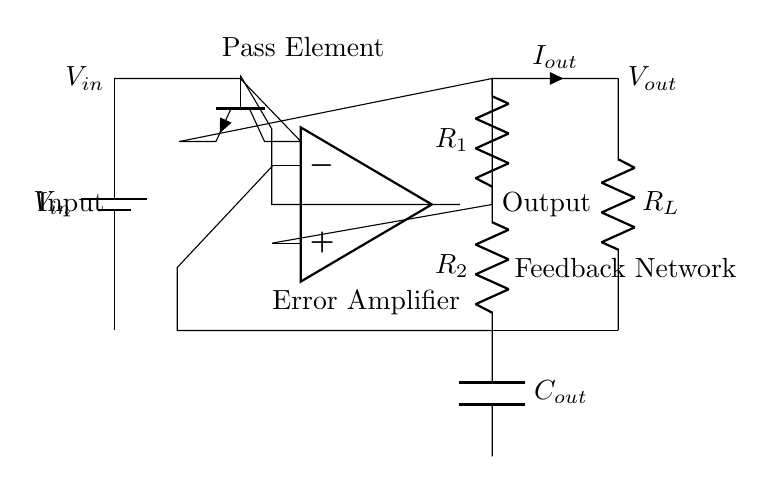What is the input voltage in this circuit? The input voltage is labeled as V_in, which indicates the source voltage provided to the circuit.
Answer: V_in What type of transistor is used as the pass element in this regulator? The circuit diagram shows an npn transistor indicated by the symbol drawn at the lower left as the pass element.
Answer: npn What does the feedback network consist of in this circuit? The feedback network consists of two resistors labeled R_1 and R_2 in the voltage divider configuration between the output and the inverting terminal of the op-amp.
Answer: Resistors R_1 and R_2 What is the purpose of the error amplifier in this circuit? The error amplifier, depicted as an op-amp, compares the output voltage to a reference voltage to control the pass element and maintain a stable output voltage.
Answer: Voltage regulation What is the output voltage in relation to the output capacitor? The output capacitor labeled as C_out is connected to the output voltage, and it helps filter the output to reduce voltage ripple caused by load changes.
Answer: Connected to V_out What happens to the output current when the load resistance R_L changes? When R_L changes, the output current I_out varies according to Ohm's law, which states that current is equal to voltage divided by resistance (I = V/R), affecting the regulation of V_out.
Answer: V_out varies 